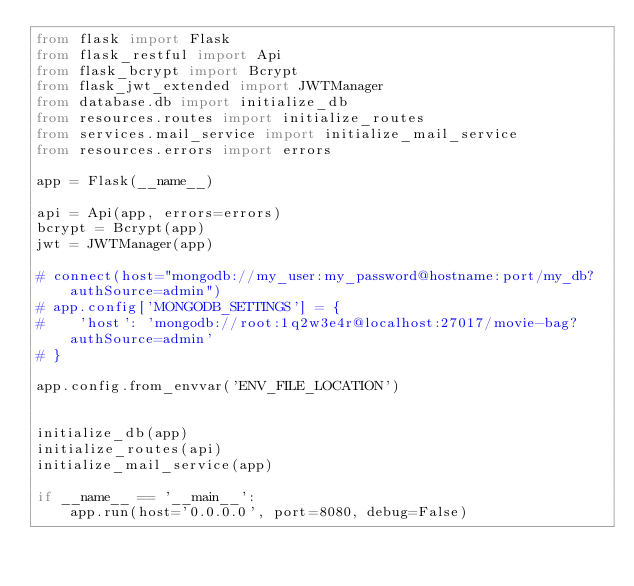Convert code to text. <code><loc_0><loc_0><loc_500><loc_500><_Python_>from flask import Flask
from flask_restful import Api
from flask_bcrypt import Bcrypt
from flask_jwt_extended import JWTManager
from database.db import initialize_db
from resources.routes import initialize_routes
from services.mail_service import initialize_mail_service
from resources.errors import errors

app = Flask(__name__)

api = Api(app, errors=errors)
bcrypt = Bcrypt(app)
jwt = JWTManager(app)

# connect(host="mongodb://my_user:my_password@hostname:port/my_db?authSource=admin")
# app.config['MONGODB_SETTINGS'] = {
#    'host': 'mongodb://root:1q2w3e4r@localhost:27017/movie-bag?authSource=admin'
# }

app.config.from_envvar('ENV_FILE_LOCATION')


initialize_db(app)
initialize_routes(api)
initialize_mail_service(app)

if __name__ == '__main__':
    app.run(host='0.0.0.0', port=8080, debug=False)
</code> 